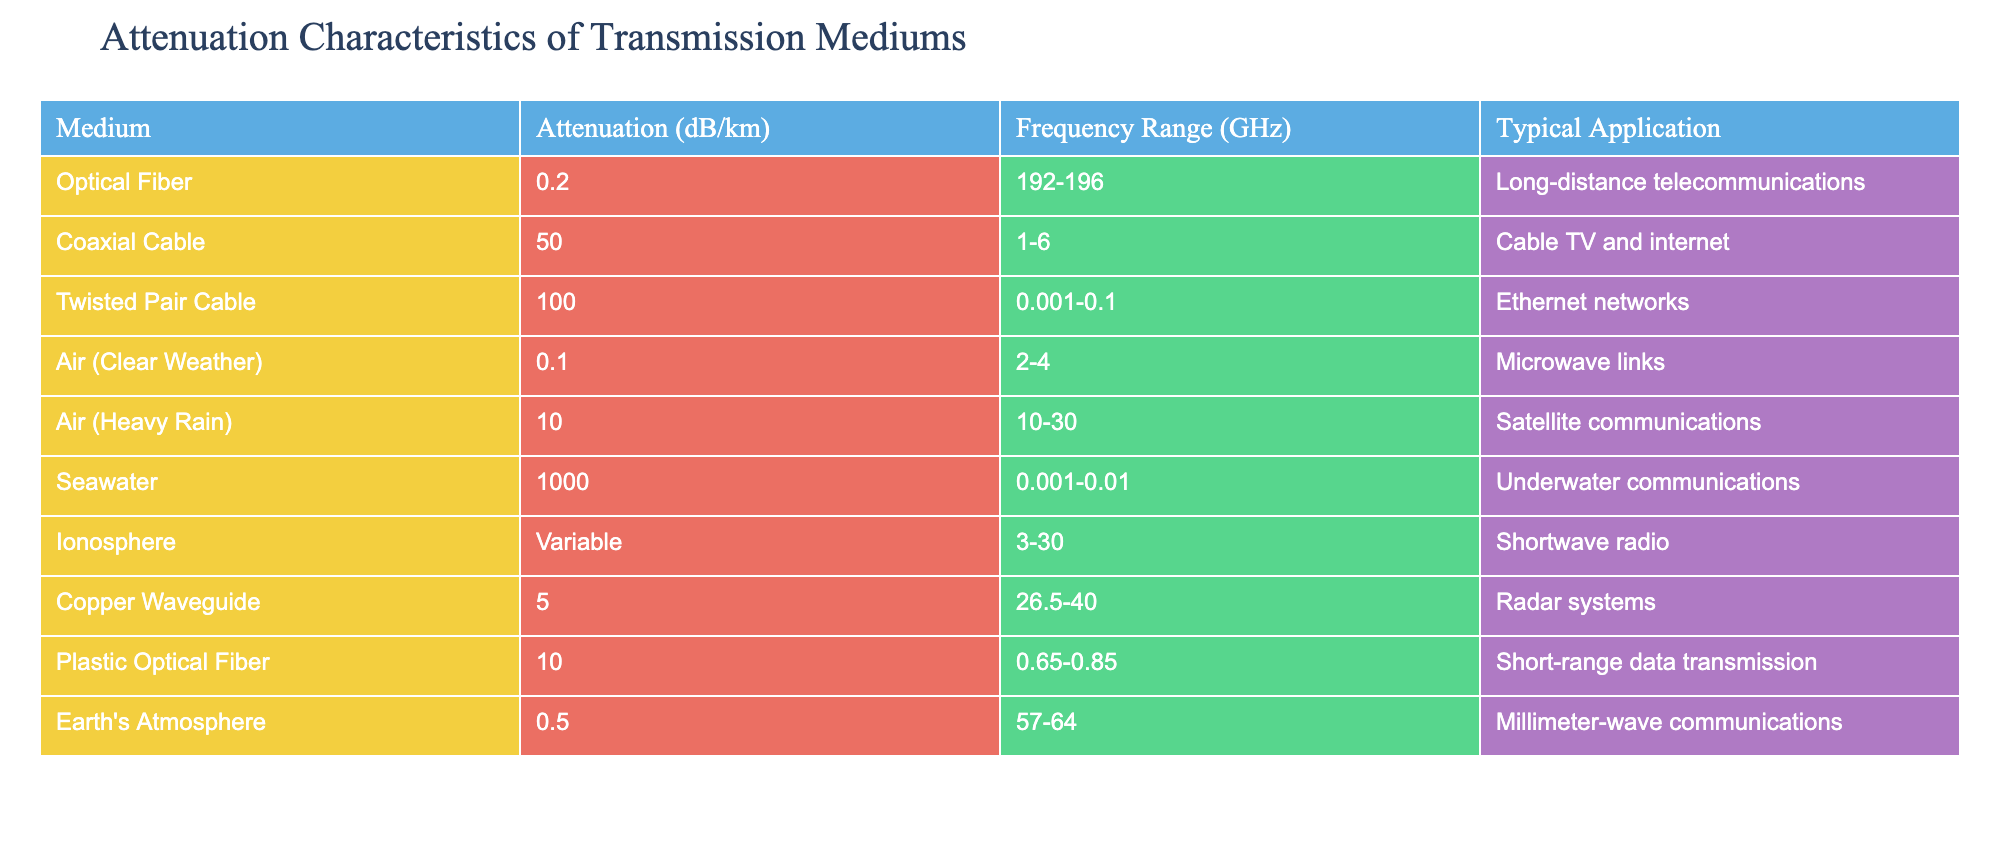What is the attenuation value of Coaxial Cable? The table lists the Coaxial Cable under the "Medium" column and states its attenuation as "50 dB/km". Thus, the value of 50 dB/km refers to its attenuation.
Answer: 50 dB/km Which medium has the lowest attenuation? Looking through the attenuation values provided for each medium, Optical Fiber has the lowest value at "0.2 dB/km", which is the smallest compared to other values.
Answer: 0.2 dB/km What is the frequency range for Twisted Pair Cable? Twisted Pair Cable is mentioned in the table under the "Medium" column. Its corresponding "Frequency Range (GHz)" is given as "0.001-0.1", which indicates the frequencies it operates within.
Answer: 0.001-0.1 GHz Is the attenuation of Seawater higher than that of Copper Waveguide? The table indicates that Seawater has an attenuation of "1000 dB/km" while Copper Waveguide has an attenuation of "5 dB/km". Since 1000 is greater than 5, the statement is true.
Answer: Yes What is the average attenuation of the two mediums with the highest attenuation values? The highest values of attenuation according to the table are Seawater (1000 dB/km) and Twisted Pair Cable (100 dB/km). The average is calculated by summing these values (1000 + 100 = 1100) and dividing by 2 (1100 / 2 = 550).
Answer: 550 dB/km Which medium is typically used in long-distance telecommunications? The table identifies Optical Fiber as the medium associated with "Long-distance telecommunications" in the "Typical Application" column, indicating its common use in that area.
Answer: Optical Fiber How does the attenuation of Air (Heavy Rain) compare to that of Air (Clear Weather)? According to the table, Air (Heavy Rain) has an attenuation of "10 dB/km", while Air (Clear Weather) has "0.1 dB/km". Since 10 is greater than 0.1, we can conclude that Air (Heavy Rain) has higher attenuation.
Answer: Higher What is the cumulative attenuation of Optical Fiber and Plastic Optical Fiber? The attenuation values for Optical Fiber and Plastic Optical Fiber are 0.2 dB/km and 10 dB/km respectively. Summing these values gives (0.2 + 10 = 10.2 dB/km).
Answer: 10.2 dB/km Does Ionosphere have a fixed attenuation value? The table specifies that the attenuation for Ionosphere is "Variable", indicating that it does not have a fixed value but changes depending on conditions. Therefore, the statement is false.
Answer: No 